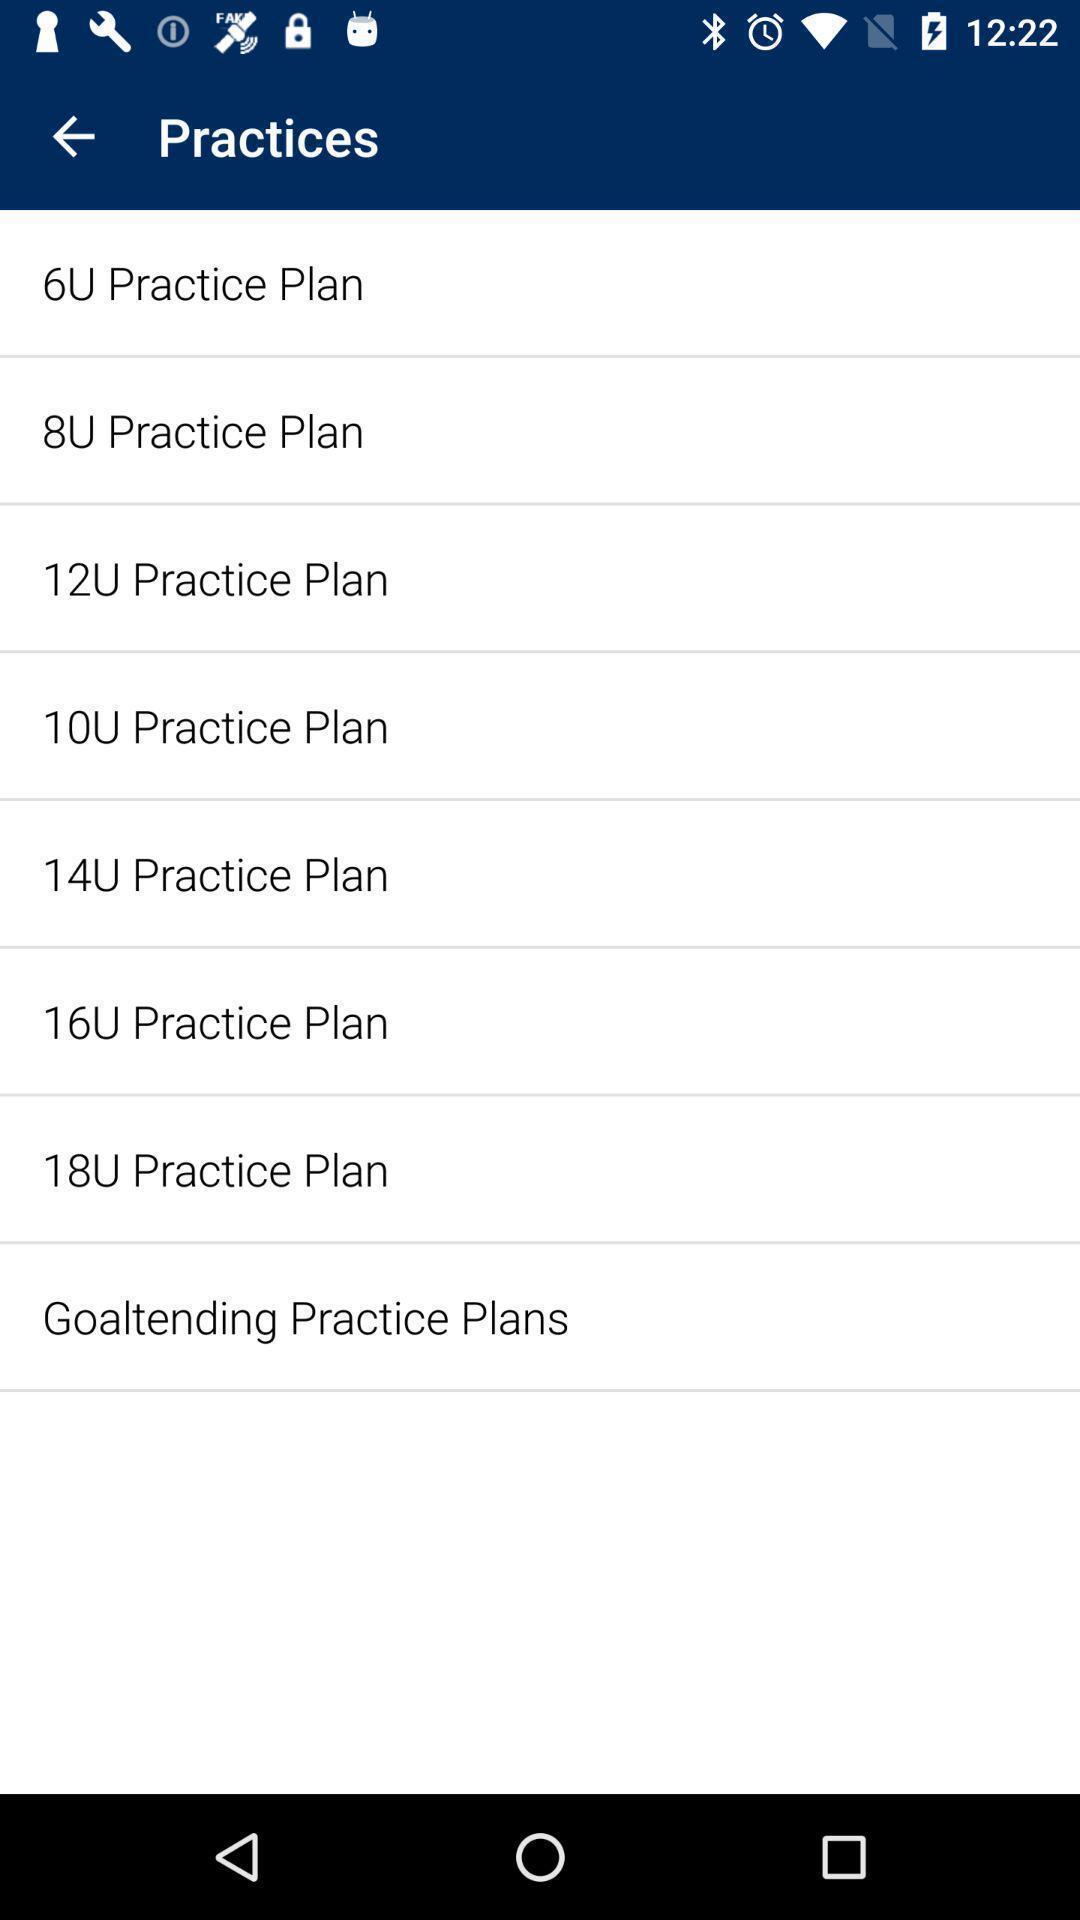Provide a textual representation of this image. Page showing list of different practice plans. 